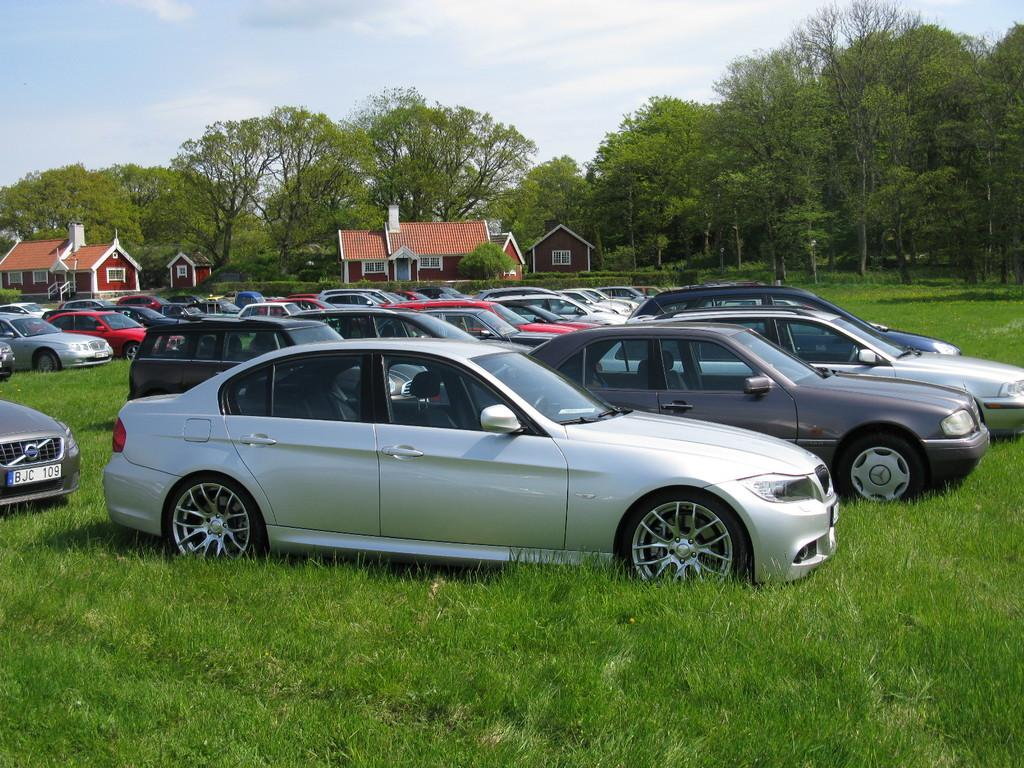What types of objects are present in the image? There are many vehicles and houses in the image. What type of natural environment is visible in the image? There is grass and trees visible in the image. What is visible in the background of the image? The sky is visible in the image. Can you see any fairies or maids wearing stockings in the image? There are no fairies or maids wearing stockings present in the image. 